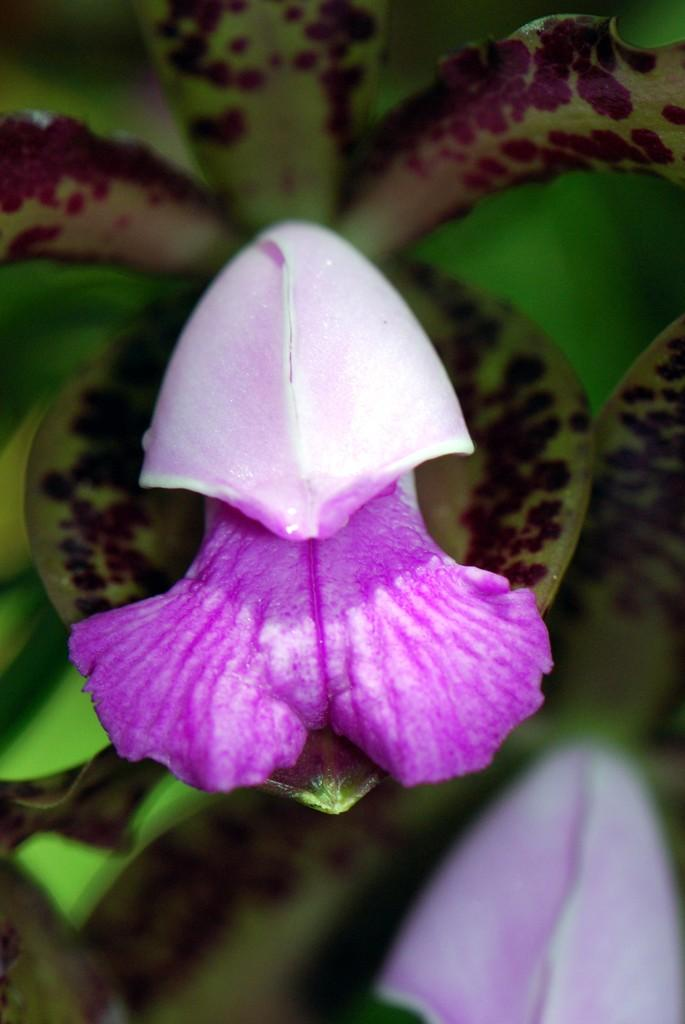What type of living organisms can be seen in the image? There are flowers and plants in the image. Can you describe the plants in the image? The plants in the image are not specified, but they are present alongside the flowers. What type of pin can be seen holding the flowers together in the image? There is no pin present in the image; the flowers are not depicted as being held together. 